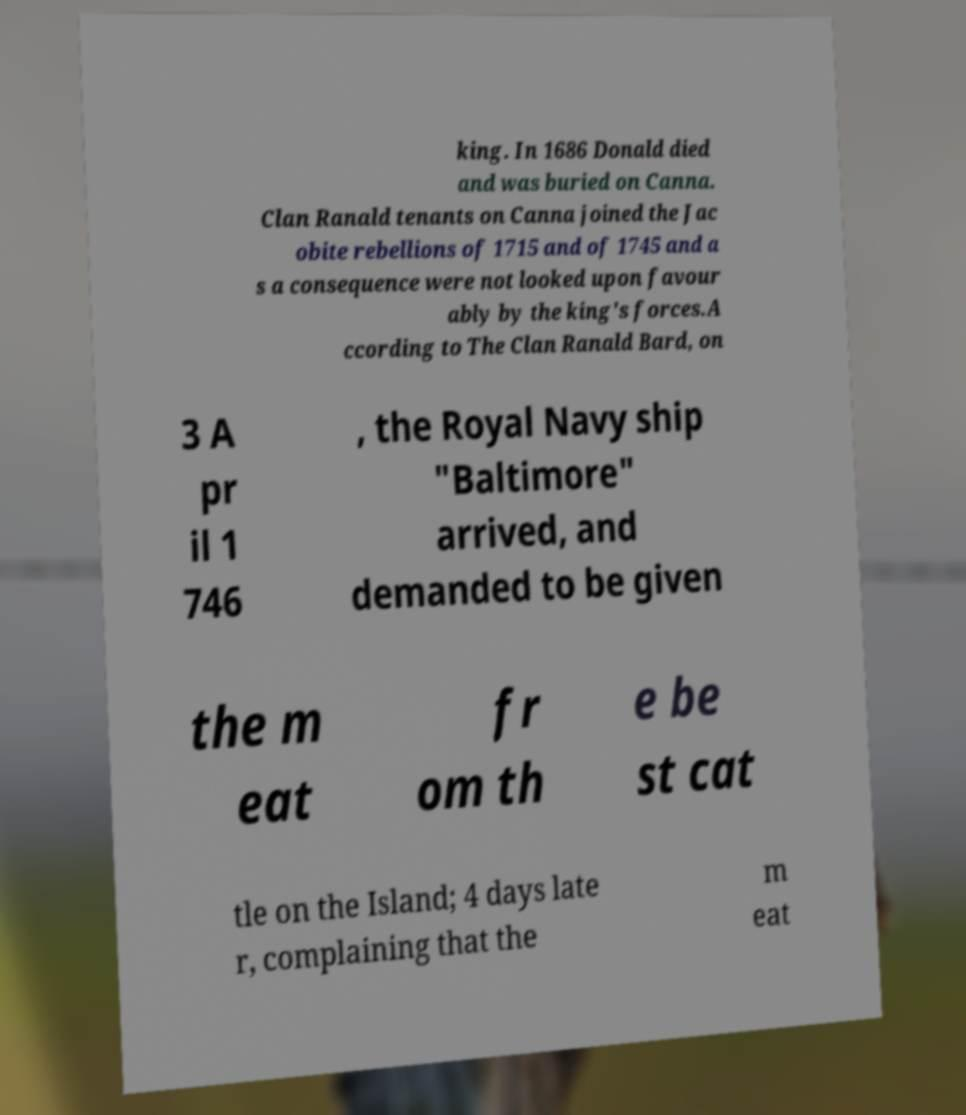Could you extract and type out the text from this image? king. In 1686 Donald died and was buried on Canna. Clan Ranald tenants on Canna joined the Jac obite rebellions of 1715 and of 1745 and a s a consequence were not looked upon favour ably by the king's forces.A ccording to The Clan Ranald Bard, on 3 A pr il 1 746 , the Royal Navy ship "Baltimore" arrived, and demanded to be given the m eat fr om th e be st cat tle on the Island; 4 days late r, complaining that the m eat 